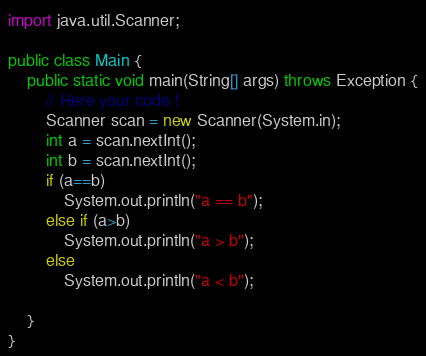<code> <loc_0><loc_0><loc_500><loc_500><_Java_>
import java.util.Scanner;

public class Main {
    public static void main(String[] args) throws Exception {
        // Here your code !
        Scanner scan = new Scanner(System.in);
        int a = scan.nextInt();
        int b = scan.nextInt();
        if (a==b)
            System.out.println("a == b");
        else if (a>b) 
            System.out.println("a > b");
        else
            System.out.println("a < b");
    
    }
}</code> 